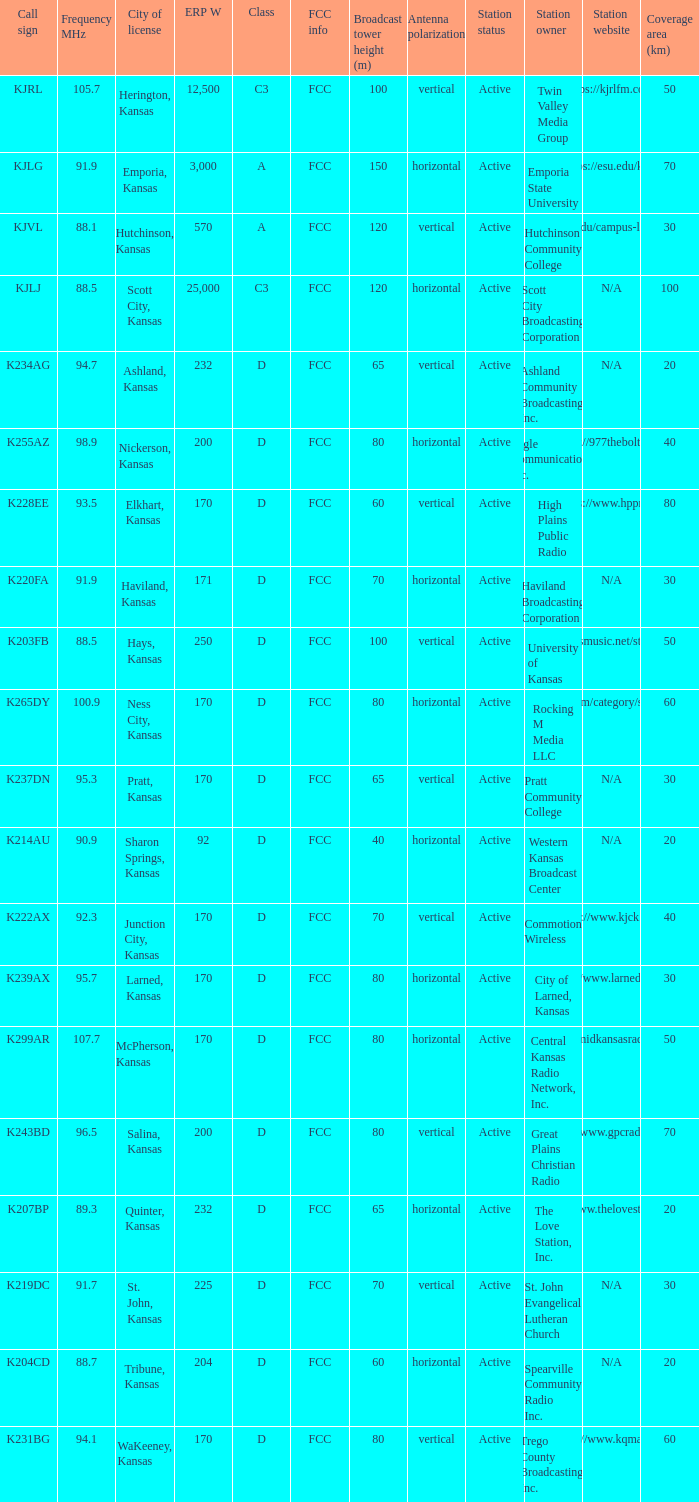ERP W that has a Class of d, and a Call sign of k299ar is what total number? 1.0. 